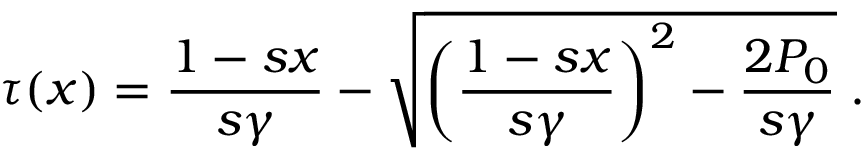Convert formula to latex. <formula><loc_0><loc_0><loc_500><loc_500>\tau ( x ) = \frac { 1 - s x } { s \gamma } - \sqrt { \left ( \frac { 1 - s x } { s \gamma } \right ) ^ { 2 } - \frac { 2 P _ { 0 } } { s \gamma } } \, .</formula> 